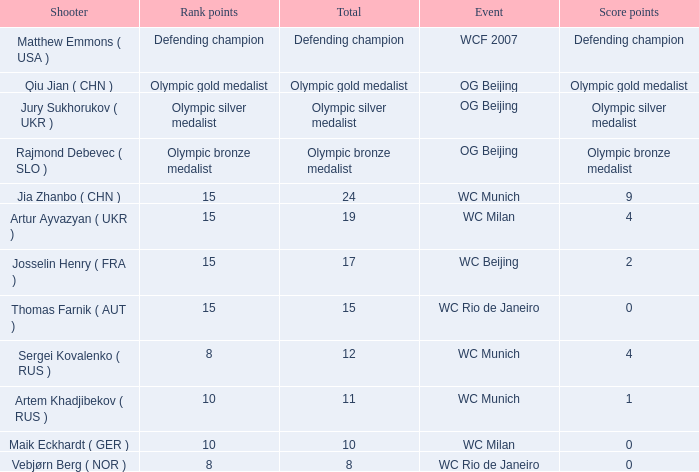With Olympic Bronze Medalist as the total what are the score points? Olympic bronze medalist. 